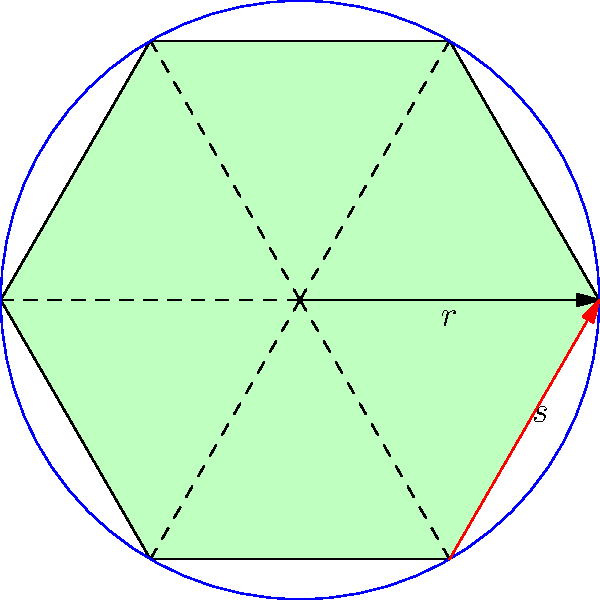In a hexagonal bee habitat design, each habitat is represented by a regular hexagon with side length $s$. If the radius of the circle inscribed in this hexagon is $r$, and the total area of the conservation site is 10,000 square meters, what is the maximum number of bee habitats that can be placed in the site if we want to maximize the total area covered by the habitats? Let's approach this step-by-step:

1) First, we need to find the relationship between $s$ and $r$. In a regular hexagon:
   
   $s = \frac{2r}{\sqrt{3}}$

2) The area of a regular hexagon with side length $s$ is:
   
   $A_{hexagon} = \frac{3\sqrt{3}}{2}s^2$

3) Substituting $s$ with $r$:
   
   $A_{hexagon} = \frac{3\sqrt{3}}{2}(\frac{2r}{\sqrt{3}})^2 = 2\sqrt{3}r^2$

4) To maximize the number of habitats, we need to minimize the area of each hexagon while ensuring they touch each other. This occurs when the hexagons are arranged in a hexagonal lattice.

5) In a hexagonal lattice, the area occupied by each hexagon (including its share of the gaps) is:
   
   $A_{occupied} = 2\sqrt{3}r^2 \cdot \frac{2}{\sqrt{3}} = 4r^2$

6) The number of habitats that can fit in the conservation area is:
   
   $N = \frac{10000}{4r^2}$

7) To maximize $N$, we need to minimize $r$ while keeping the habitats large enough for bees. Let's assume the minimum viable radius is 0.5 meters.

8) With $r = 0.5m$, we get:
   
   $N = \frac{10000}{4(0.5)^2} = 10000$

9) However, we need to round down to the nearest whole number as we can't have partial habitats.
Answer: 9999 habitats 